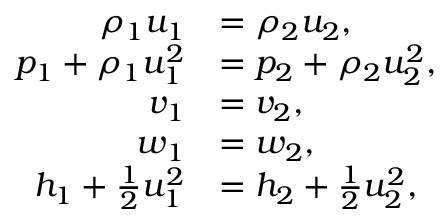Convert formula to latex. <formula><loc_0><loc_0><loc_500><loc_500>\begin{array} { r l } { \rho _ { 1 } u _ { 1 } } & { = \rho _ { 2 } u _ { 2 } , } \\ { p _ { 1 } + \rho _ { 1 } u _ { 1 } ^ { 2 } } & { = p _ { 2 } + \rho _ { 2 } u _ { 2 } ^ { 2 } , } \\ { v _ { 1 } } & { = v _ { 2 } , } \\ { w _ { 1 } } & { = w _ { 2 } , } \\ { h _ { 1 } + \frac { 1 } { 2 } u _ { 1 } ^ { 2 } } & { = h _ { 2 } + \frac { 1 } { 2 } u _ { 2 } ^ { 2 } , } \end{array}</formula> 